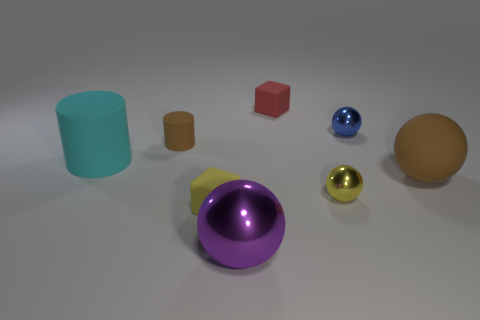Subtract 1 balls. How many balls are left? 3 Add 2 small cylinders. How many objects exist? 10 Subtract all cubes. How many objects are left? 6 Subtract all yellow objects. Subtract all tiny gray rubber things. How many objects are left? 6 Add 4 metal things. How many metal things are left? 7 Add 3 cubes. How many cubes exist? 5 Subtract 0 green cylinders. How many objects are left? 8 